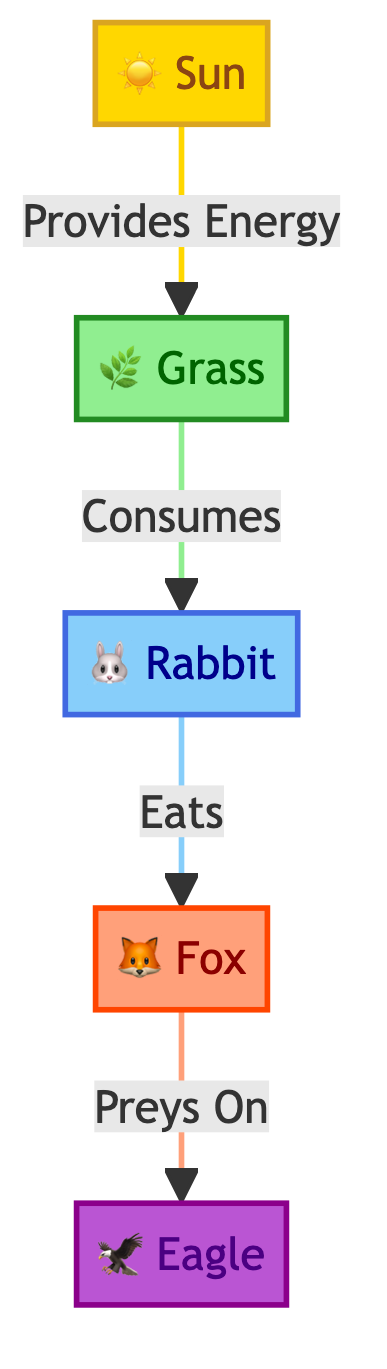What is the primary energy source in this food chain? The primary energy source is represented by the first node in the diagram, which is the sun. It provides energy for the entire food chain and is connected to the grass, the producer.
Answer: Sun How many consumers are present in the food chain? There are two consumer nodes: the rabbit (primary consumer) and the fox (secondary consumer). These nodes receive energy by consuming other organisms.
Answer: 2 Which organism acts as the secondary consumer? The secondary consumer is the organism that preys on the primary consumer, in this case, the fox, which eats the rabbit. This can be identified by tracing the arrows from the rabbit node.
Answer: Fox What type of organism is the grass classified as? The grass is identified as the producer in the food chain because it produces energy through photosynthesis, which is the first step in this energy flow diagram.
Answer: Producer Which organism is at the top of the food chain? The apex predator is at the top of the food chain, which can be determined by finding the organism that is not preyed upon by any others in the diagram, which is the eagle.
Answer: Eagle What links the rabbit to the fox in the food chain? The relationship that links the rabbit to the fox is specified by the phrase "Eats," indicating the hunting relationship in which the fox preys on the rabbit.
Answer: Eats How many total nodes are represented in the diagram? To find the total number of nodes, we can count all the distinct organisms and energy sources: Sun, Grass, Rabbit, Fox, and Eagle, which totals five nodes.
Answer: 5 What is the flow of energy from the Sun to the Eagle? The flow of energy can be tracked as follows: the Sun provides energy to the grass, the grass is consumed by the rabbit, the rabbit is eaten by the fox, and finally, the fox is preyed upon by the eagle.
Answer: Sun → Grass → Rabbit → Fox → Eagle What color represents the apex predator in the diagram? The apex predator is represented by a specific color coding in the diagram. The eagle is shown in a purple hue, denoting its status at the top of the food chain.
Answer: Purple 